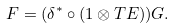Convert formula to latex. <formula><loc_0><loc_0><loc_500><loc_500>F = ( \delta ^ { * } \circ ( 1 \otimes T E ) ) G .</formula> 